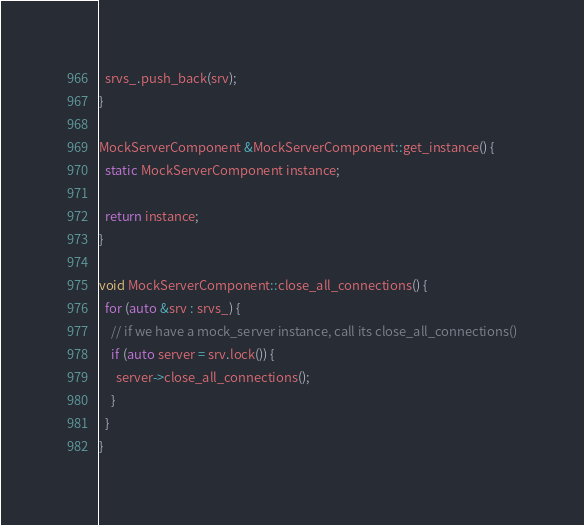<code> <loc_0><loc_0><loc_500><loc_500><_C++_>  srvs_.push_back(srv);
}

MockServerComponent &MockServerComponent::get_instance() {
  static MockServerComponent instance;

  return instance;
}

void MockServerComponent::close_all_connections() {
  for (auto &srv : srvs_) {
    // if we have a mock_server instance, call its close_all_connections()
    if (auto server = srv.lock()) {
      server->close_all_connections();
    }
  }
}
</code> 